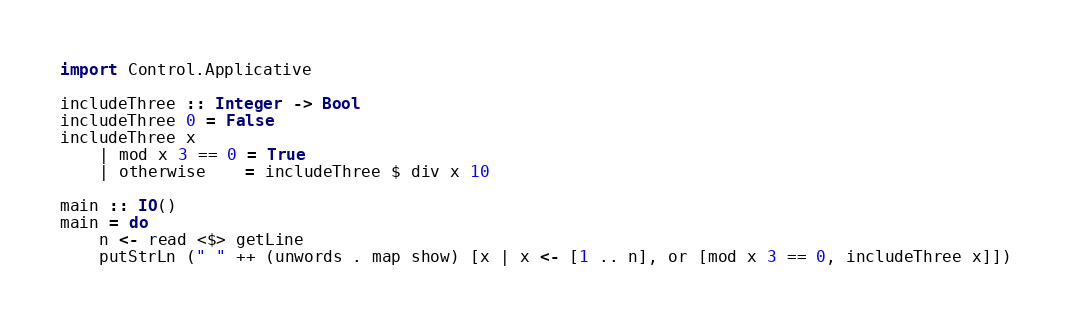<code> <loc_0><loc_0><loc_500><loc_500><_Haskell_>import Control.Applicative

includeThree :: Integer -> Bool
includeThree 0 = False
includeThree x
    | mod x 3 == 0 = True
    | otherwise    = includeThree $ div x 10

main :: IO()
main = do
    n <- read <$> getLine
    putStrLn (" " ++ (unwords . map show) [x | x <- [1 .. n], or [mod x 3 == 0, includeThree x]])</code> 